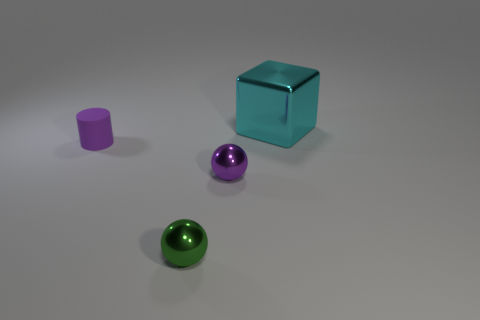Add 3 small red cubes. How many objects exist? 7 Subtract all cylinders. How many objects are left? 3 Subtract 0 red cubes. How many objects are left? 4 Subtract all small green metal cylinders. Subtract all large metallic things. How many objects are left? 3 Add 2 small metallic balls. How many small metallic balls are left? 4 Add 2 purple cylinders. How many purple cylinders exist? 3 